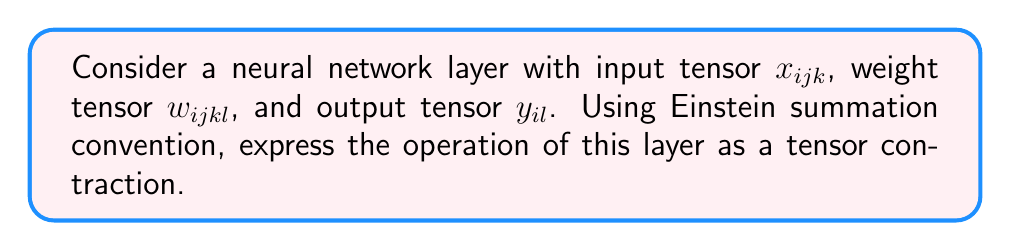Show me your answer to this math problem. Let's approach this step-by-step:

1) In a neural network layer, the output is typically computed as a linear combination of inputs, followed by an activation function. We'll focus on the linear part for this question.

2) The input tensor $x_{ijk}$ has three indices, which could represent:
   i: batch size
   j, k: spatial dimensions of the input (e.g., height and width for 2D data)

3) The weight tensor $w_{ijkl}$ has four indices:
   i: corresponds to the batch size (shared across the batch)
   j, k: correspond to the spatial dimensions of the input
   l: output feature dimension

4) The output tensor $y_{il}$ has two indices:
   i: batch size
   l: output feature dimension

5) To perform the layer operation, we need to sum over the spatial dimensions (j and k) of the input and weights. This is where Einstein summation convention comes in handy.

6) In Einstein notation, repeated indices are implicitly summed over. So, we can write the operation as:

   $$y_{il} = x_{ijk} w_{ijkl}$$

7) This notation implicitly means we're summing over j and k, while i and l remain free indices in the output.

8) Expanded, this operation would be equivalent to:

   $$y_{il} = \sum_{j}\sum_{k} x_{ijk} w_{ijkl}$$

9) This represents a tensor contraction between the 3D input tensor and the 4D weight tensor, resulting in a 2D output tensor.
Answer: $y_{il} = x_{ijk} w_{ijkl}$ 